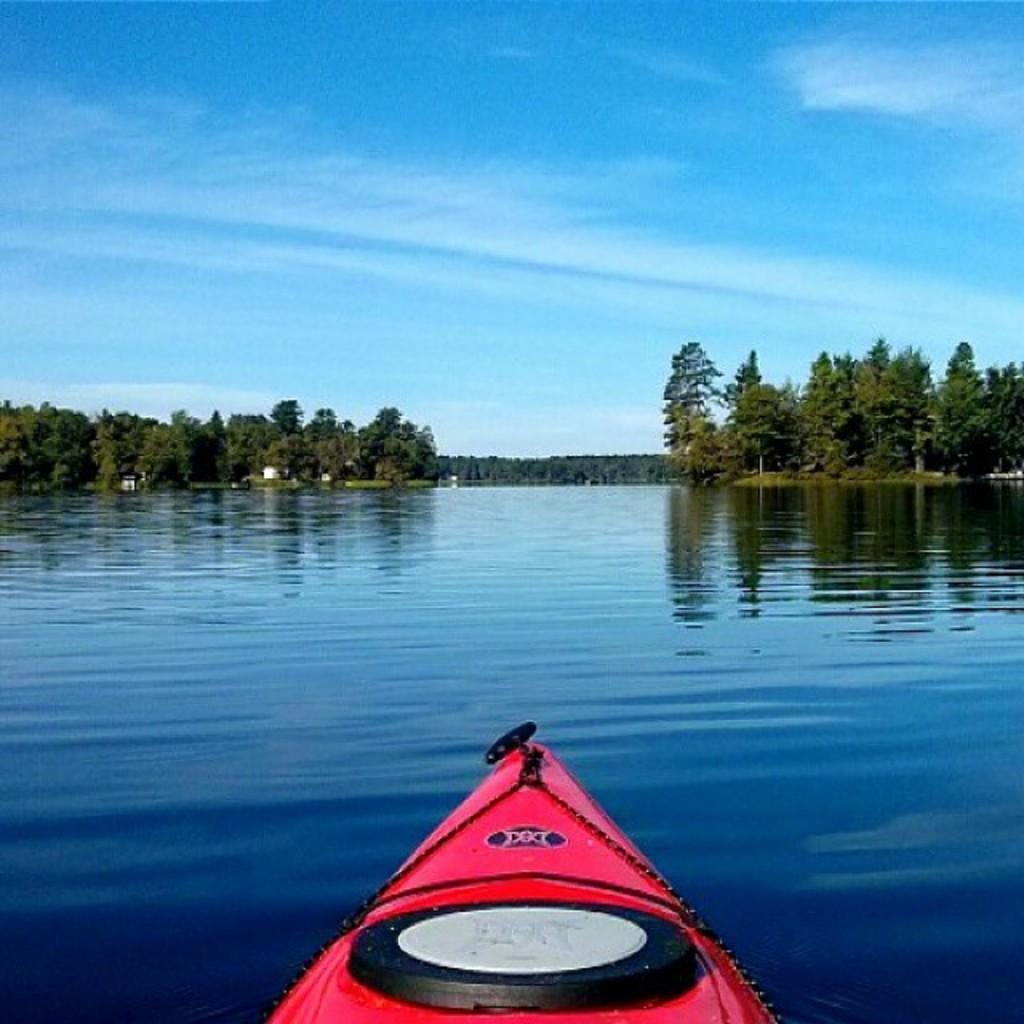What is the main subject of the image? The main subject of the image is a ship. Where is the ship located in the image? The ship is on the water surface in the image. What type of natural environment can be seen in the image? There are trees visible in the image. What type of machine is being used by the ship's leg in the image? There is no machine or leg present on the ship in the image. 